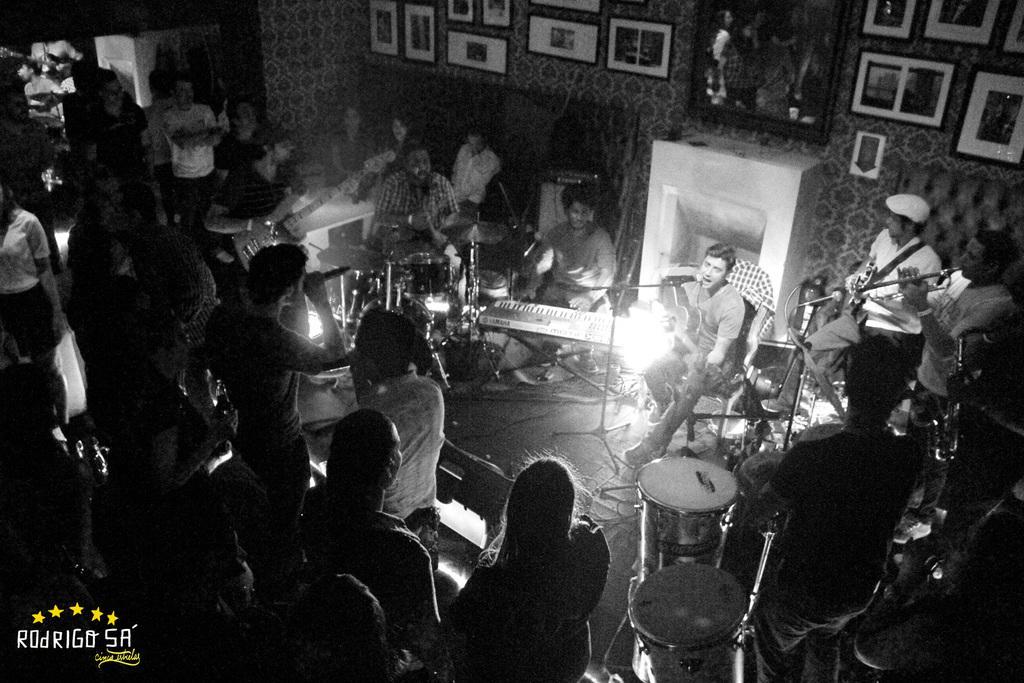Please provide a concise description of this image. This is a black and white picture. In this picture we can see the frames on the wall. We can see the musical instruments, microphones, people and few objects. On the right side of the picture we can see a man is playing a guitar and singing. In the bottom left corner of the picture we can see watermark. 